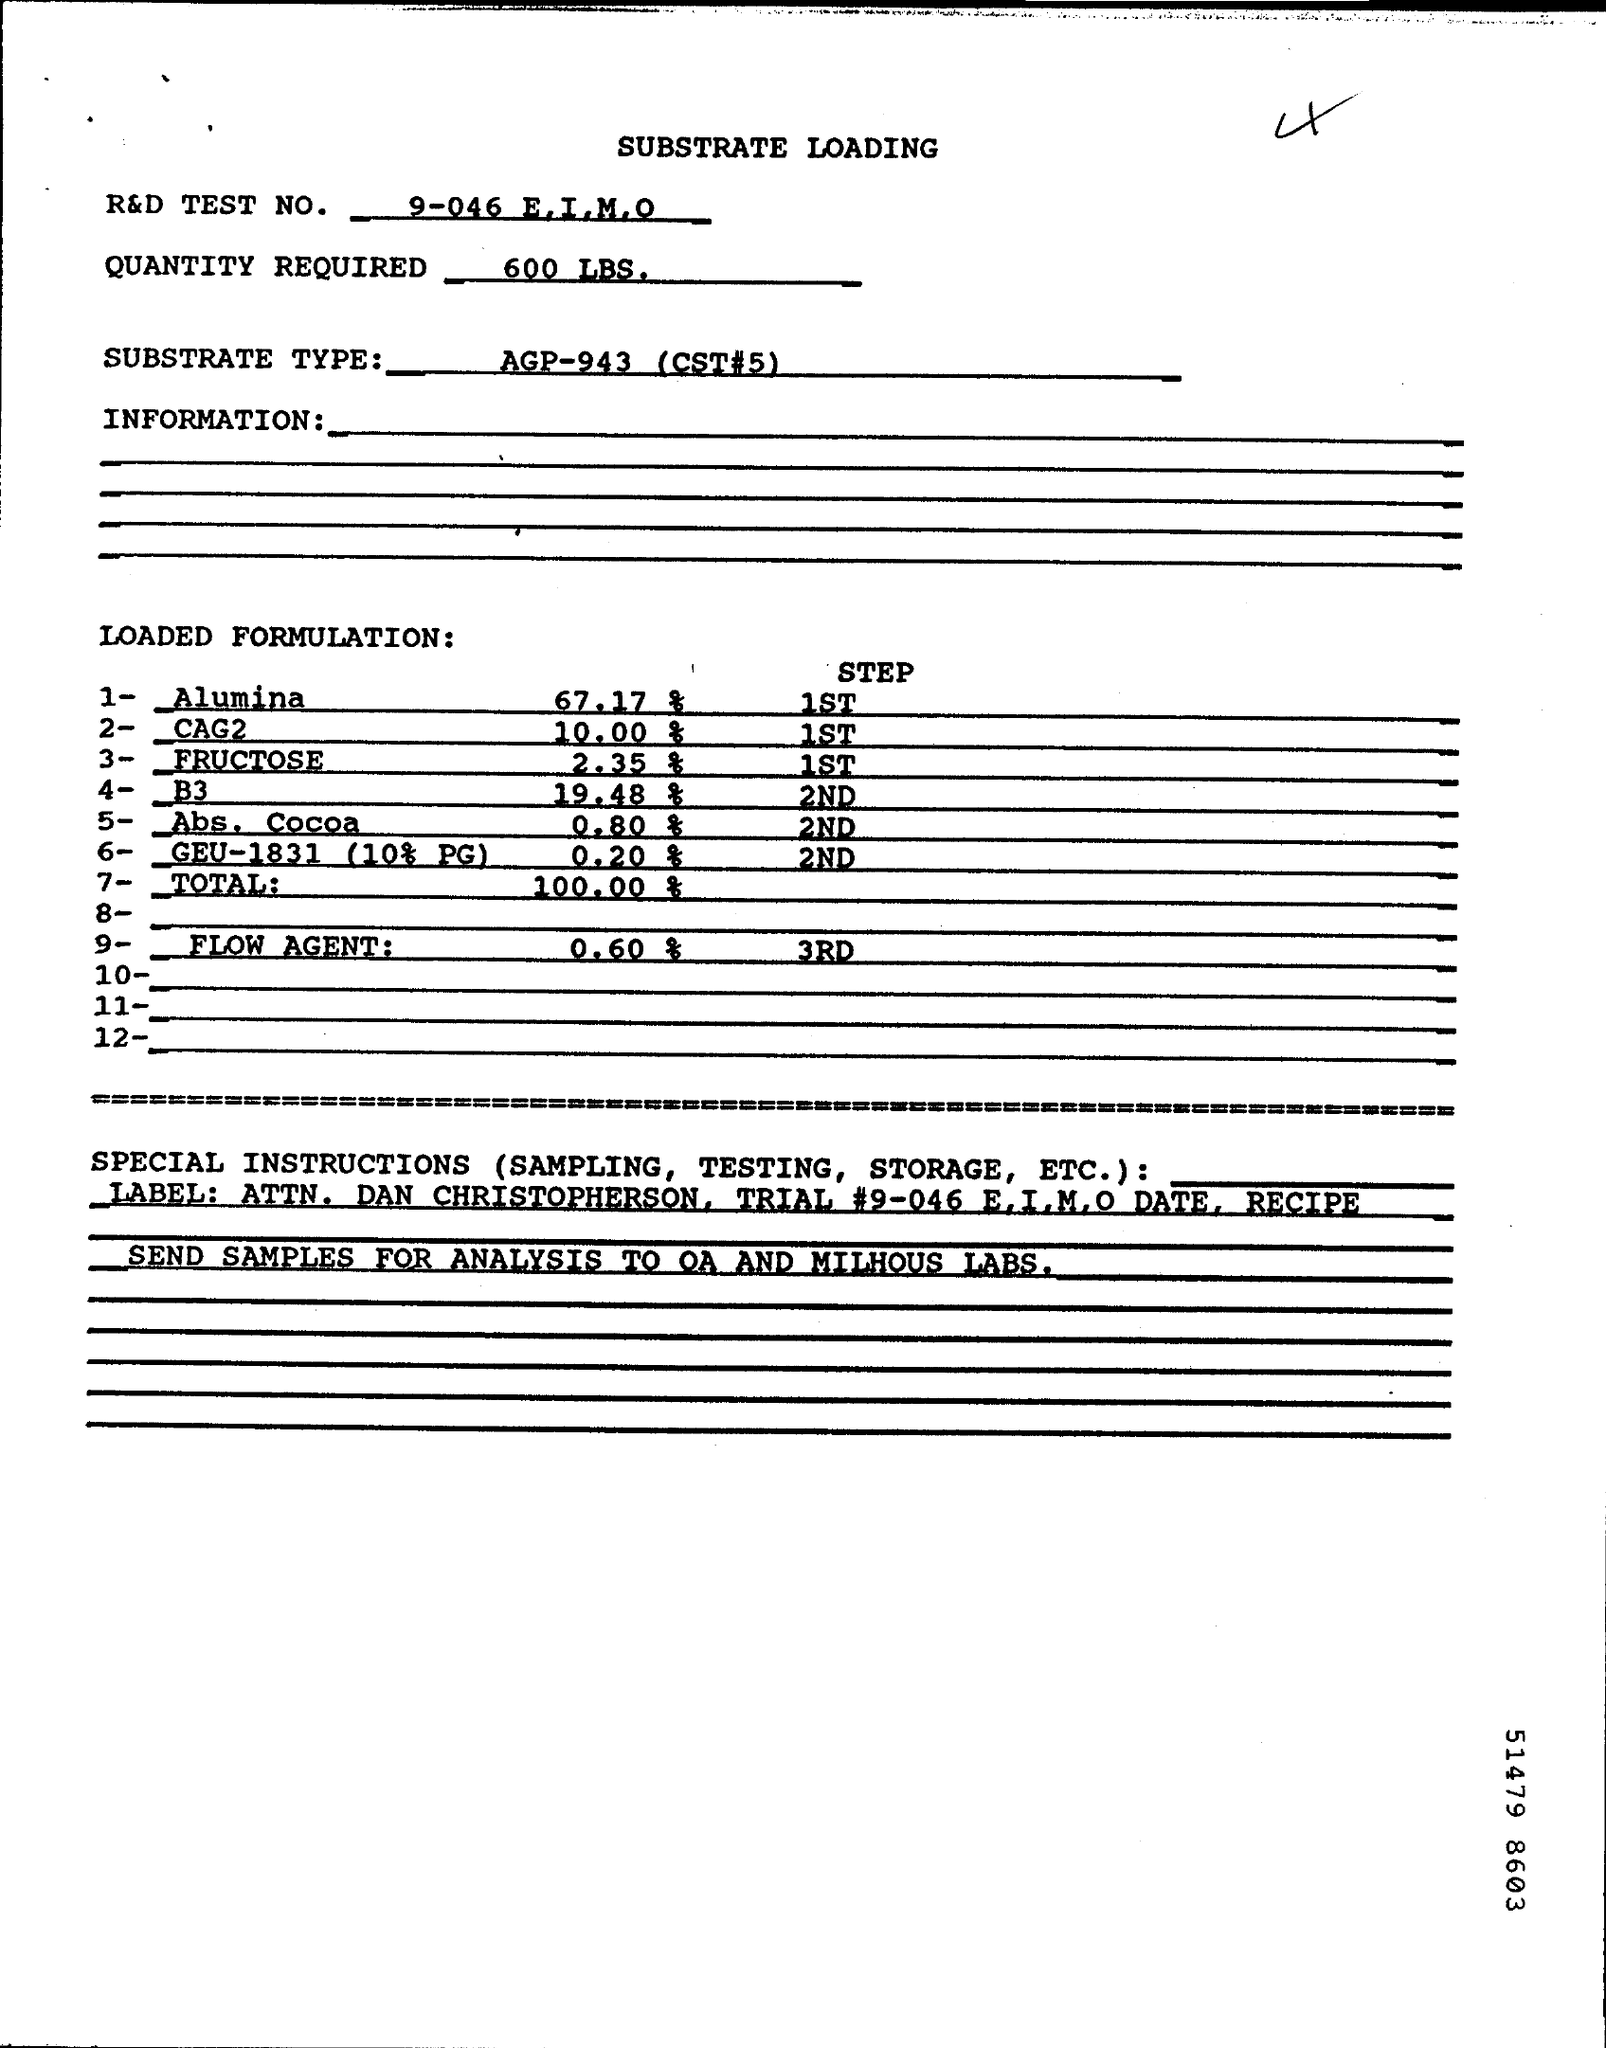Point out several critical features in this image. The required quantity for testing is 600 pounds of [insert material here]. 